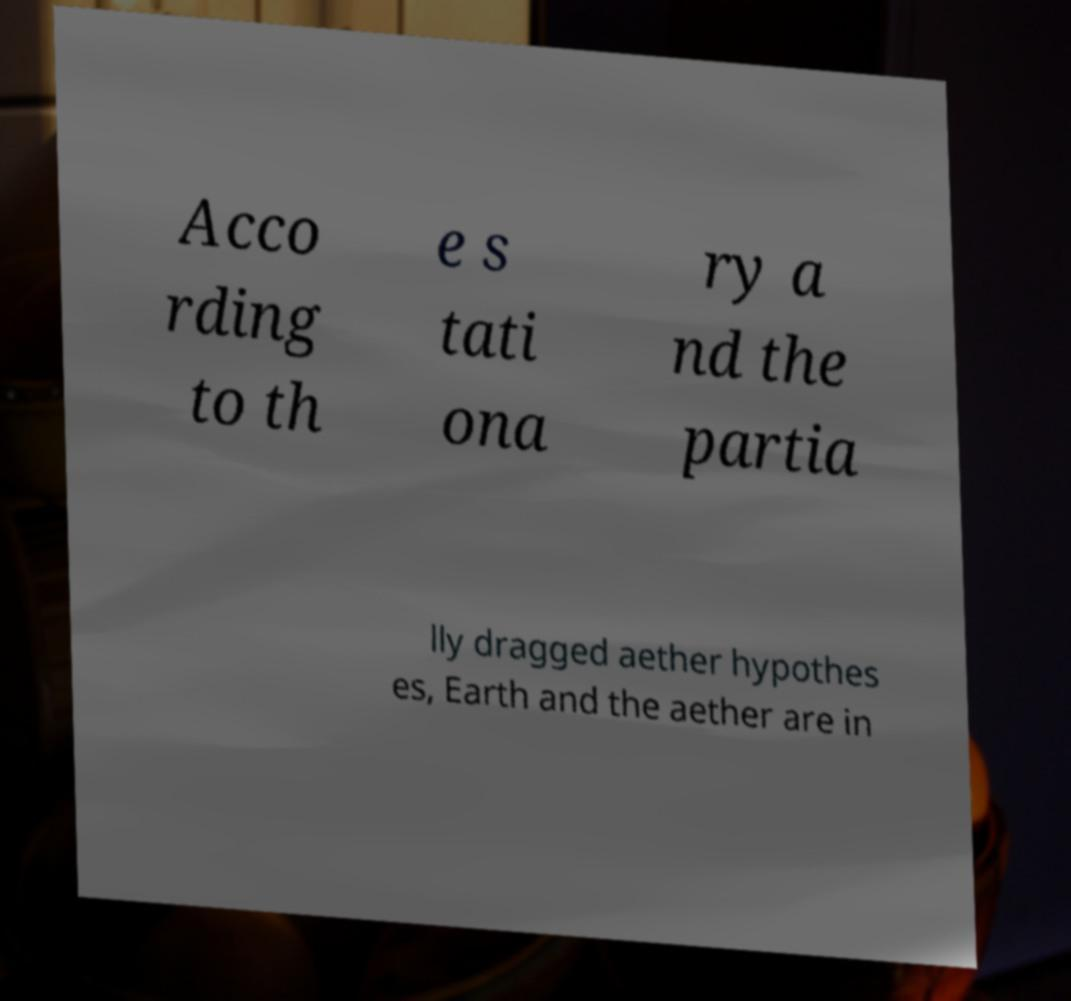Can you read and provide the text displayed in the image?This photo seems to have some interesting text. Can you extract and type it out for me? Acco rding to th e s tati ona ry a nd the partia lly dragged aether hypothes es, Earth and the aether are in 